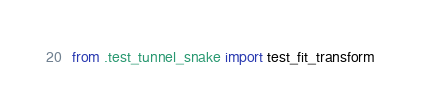<code> <loc_0><loc_0><loc_500><loc_500><_Python_>from .test_tunnel_snake import test_fit_transform</code> 